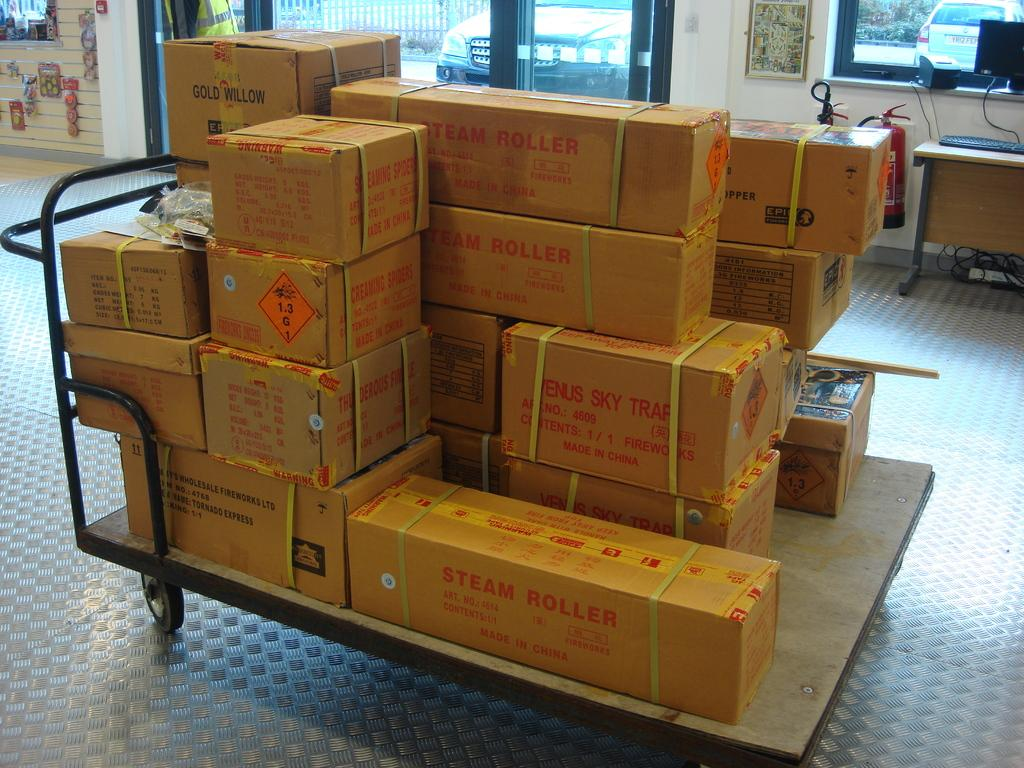Provide a one-sentence caption for the provided image. A collection of boxes sit on a wheeled cart, one of them labeled steam roller. 